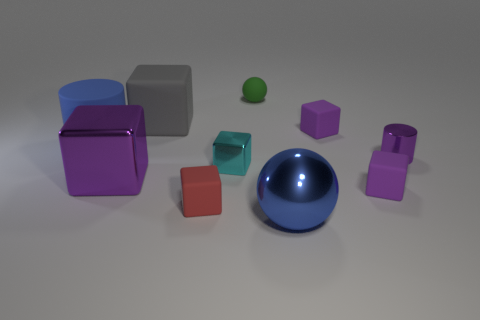What is the relative size relationship among the objects? The objects display a variety of sizes; we have smaller cubes and spheres that could perhaps fit in your hand, while the larger cubes seem as though they'd require both arms to embrace. The large blue sphere is notably the biggest object, serving as a focal point among the rest. 